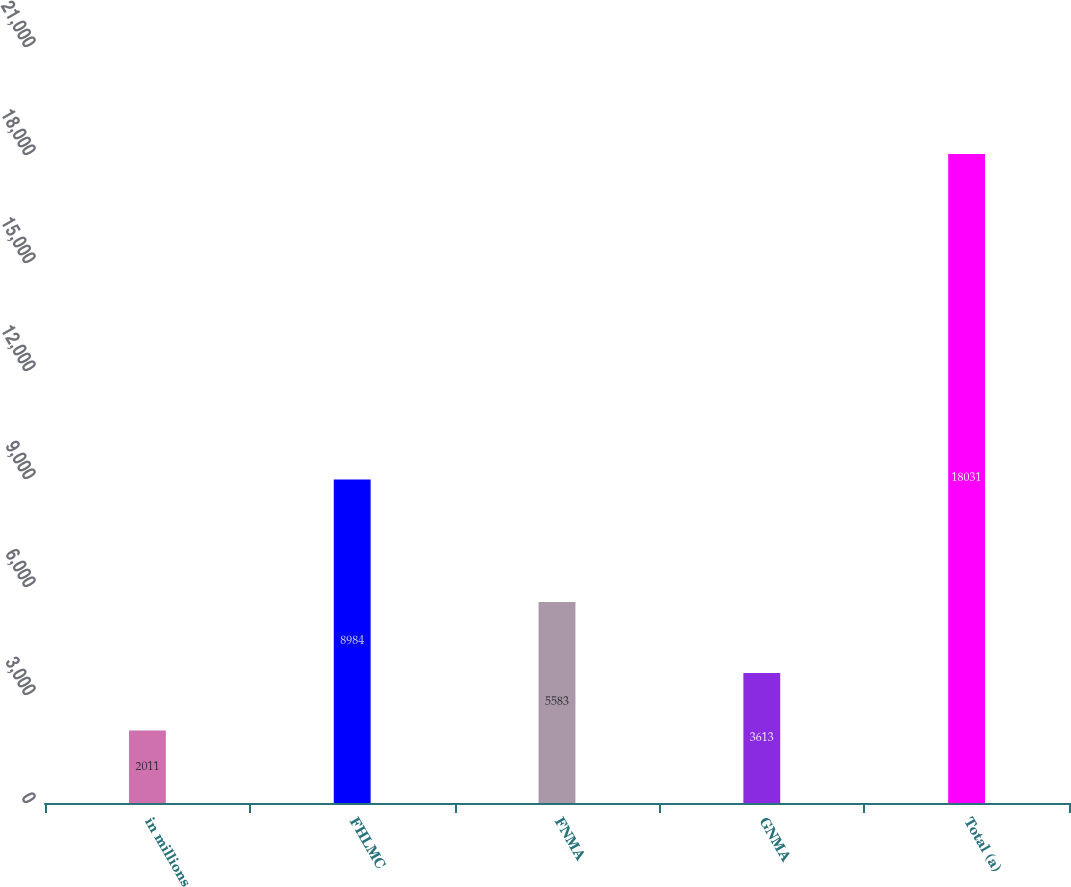Convert chart. <chart><loc_0><loc_0><loc_500><loc_500><bar_chart><fcel>in millions<fcel>FHLMC<fcel>FNMA<fcel>GNMA<fcel>Total (a)<nl><fcel>2011<fcel>8984<fcel>5583<fcel>3613<fcel>18031<nl></chart> 